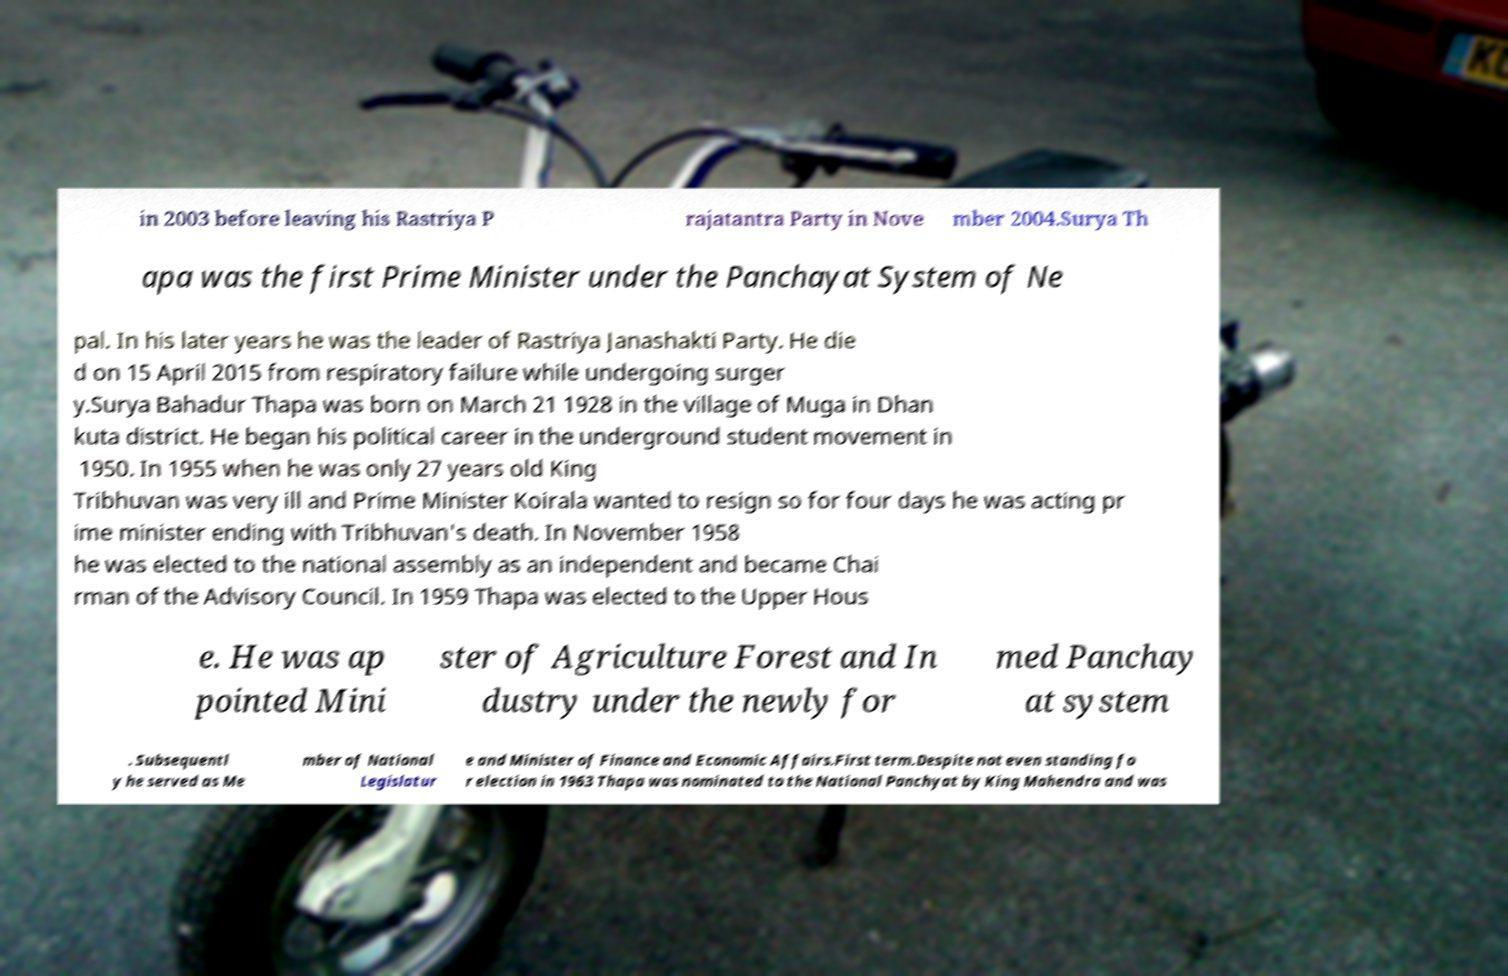Can you read and provide the text displayed in the image?This photo seems to have some interesting text. Can you extract and type it out for me? in 2003 before leaving his Rastriya P rajatantra Party in Nove mber 2004.Surya Th apa was the first Prime Minister under the Panchayat System of Ne pal. In his later years he was the leader of Rastriya Janashakti Party. He die d on 15 April 2015 from respiratory failure while undergoing surger y.Surya Bahadur Thapa was born on March 21 1928 in the village of Muga in Dhan kuta district. He began his political career in the underground student movement in 1950. In 1955 when he was only 27 years old King Tribhuvan was very ill and Prime Minister Koirala wanted to resign so for four days he was acting pr ime minister ending with Tribhuvan's death. In November 1958 he was elected to the national assembly as an independent and became Chai rman of the Advisory Council. In 1959 Thapa was elected to the Upper Hous e. He was ap pointed Mini ster of Agriculture Forest and In dustry under the newly for med Panchay at system . Subsequentl y he served as Me mber of National Legislatur e and Minister of Finance and Economic Affairs.First term.Despite not even standing fo r election in 1963 Thapa was nominated to the National Panchyat by King Mahendra and was 